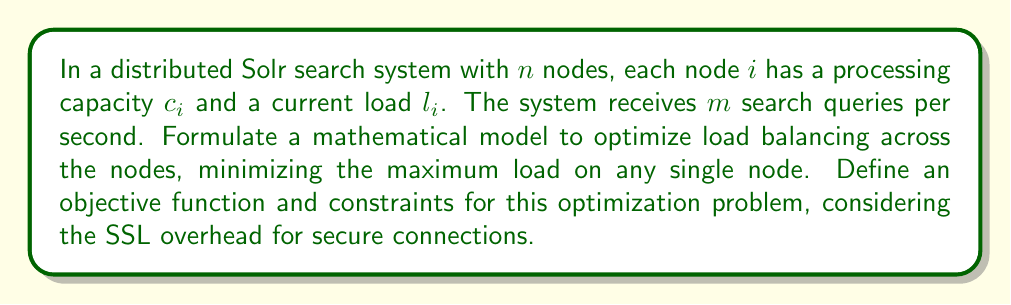Show me your answer to this math problem. To optimize load balancing in a distributed Solr search system, we can formulate a linear programming problem. Let's break down the problem and define the necessary components:

1. Variables:
   Let $x_{ij}$ be the fraction of queries assigned to node $i$ for query type $j$.

2. Parameters:
   - $n$: number of nodes
   - $m$: number of queries per second
   - $c_i$: processing capacity of node $i$
   - $l_i$: current load on node $i$
   - $w_j$: weight of query type $j$ (computational complexity)
   - $s$: SSL overhead factor (e.g., 1.1 for 10% overhead)

3. Objective function:
   Minimize the maximum load on any single node:
   $$\min \max_{i=1}^n \left(l_i + s \sum_{j=1}^m w_j x_{ij}\right)$$

4. Constraints:
   a) All queries must be assigned:
      $$\sum_{i=1}^n x_{ij} = 1, \quad \forall j = 1, \ldots, m$$
   
   b) Node capacity constraints:
      $$l_i + s \sum_{j=1}^m w_j x_{ij} \leq c_i, \quad \forall i = 1, \ldots, n$$
   
   c) Non-negativity constraints:
      $$x_{ij} \geq 0, \quad \forall i = 1, \ldots, n, \quad \forall j = 1, \ldots, m$$

5. Linearization:
   To solve this as a linear programming problem, we introduce an auxiliary variable $z$ to represent the maximum load:
   
   Objective function: $\min z$
   
   Additional constraint:
   $$l_i + s \sum_{j=1}^m w_j x_{ij} \leq z, \quad \forall i = 1, \ldots, n$$

The resulting linear programming problem can be solved using standard optimization techniques such as the simplex method or interior point methods.
Answer: The optimized load balancing model for a distributed Solr search system is:

Objective function: $\min z$

Subject to constraints:
1. $\sum_{i=1}^n x_{ij} = 1, \quad \forall j = 1, \ldots, m$
2. $l_i + s \sum_{j=1}^m w_j x_{ij} \leq c_i, \quad \forall i = 1, \ldots, n$
3. $l_i + s \sum_{j=1}^m w_j x_{ij} \leq z, \quad \forall i = 1, \ldots, n$
4. $x_{ij} \geq 0, \quad \forall i = 1, \ldots, n, \quad \forall j = 1, \ldots, m$

Where $z$ represents the maximum load on any single node, which is to be minimized. 